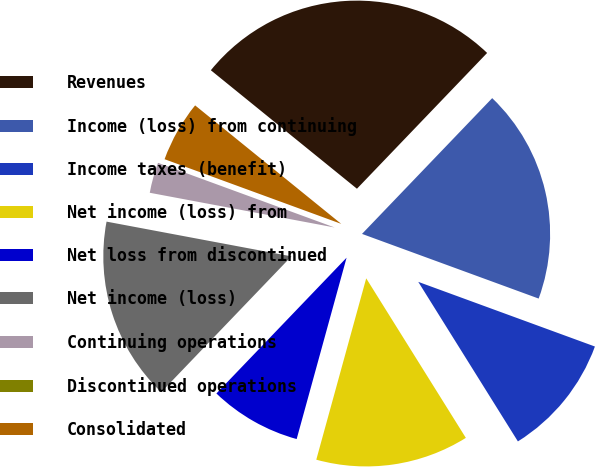<chart> <loc_0><loc_0><loc_500><loc_500><pie_chart><fcel>Revenues<fcel>Income (loss) from continuing<fcel>Income taxes (benefit)<fcel>Net income (loss) from<fcel>Net loss from discontinued<fcel>Net income (loss)<fcel>Continuing operations<fcel>Discontinued operations<fcel>Consolidated<nl><fcel>26.32%<fcel>18.42%<fcel>10.53%<fcel>13.16%<fcel>7.89%<fcel>15.79%<fcel>2.63%<fcel>0.0%<fcel>5.26%<nl></chart> 